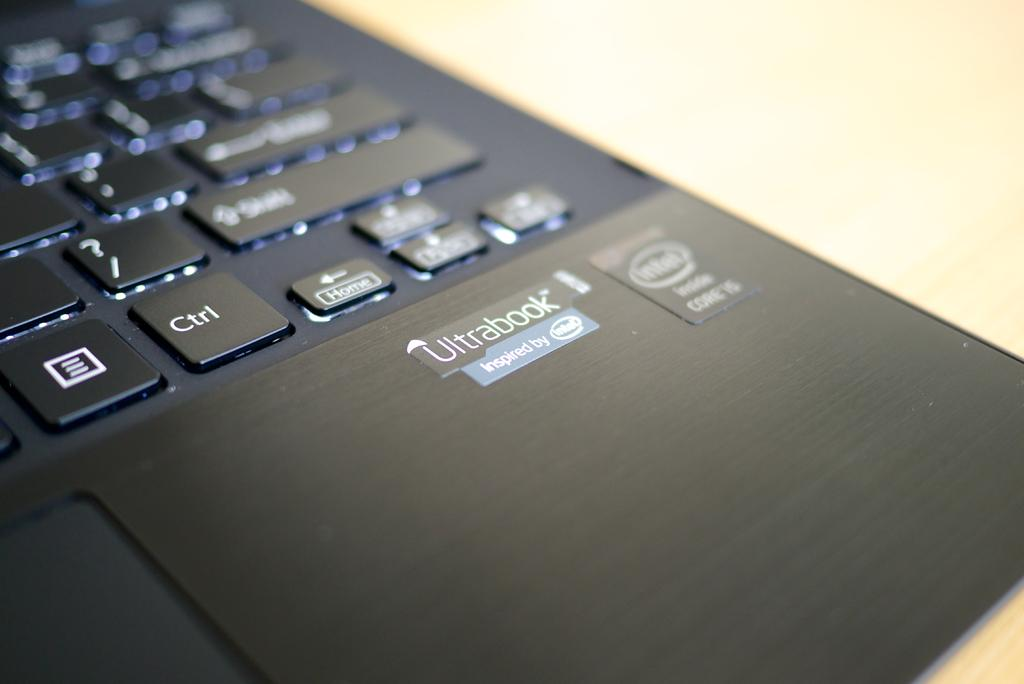<image>
Provide a brief description of the given image. A logo on a black device marks it as an Ultrabook. 